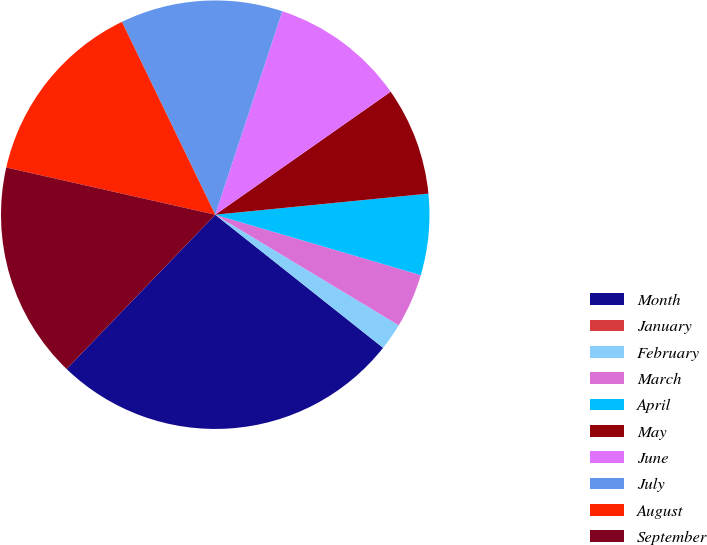Convert chart to OTSL. <chart><loc_0><loc_0><loc_500><loc_500><pie_chart><fcel>Month<fcel>January<fcel>February<fcel>March<fcel>April<fcel>May<fcel>June<fcel>July<fcel>August<fcel>September<nl><fcel>26.53%<fcel>0.0%<fcel>2.04%<fcel>4.08%<fcel>6.12%<fcel>8.16%<fcel>10.2%<fcel>12.24%<fcel>14.29%<fcel>16.33%<nl></chart> 